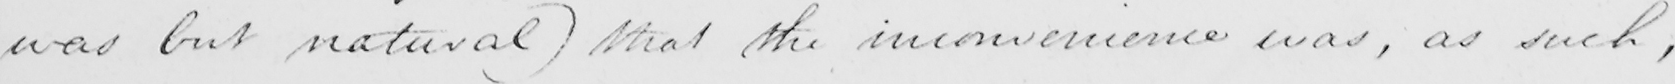Please provide the text content of this handwritten line. was but natural )  that the inconvenience was , as such , 